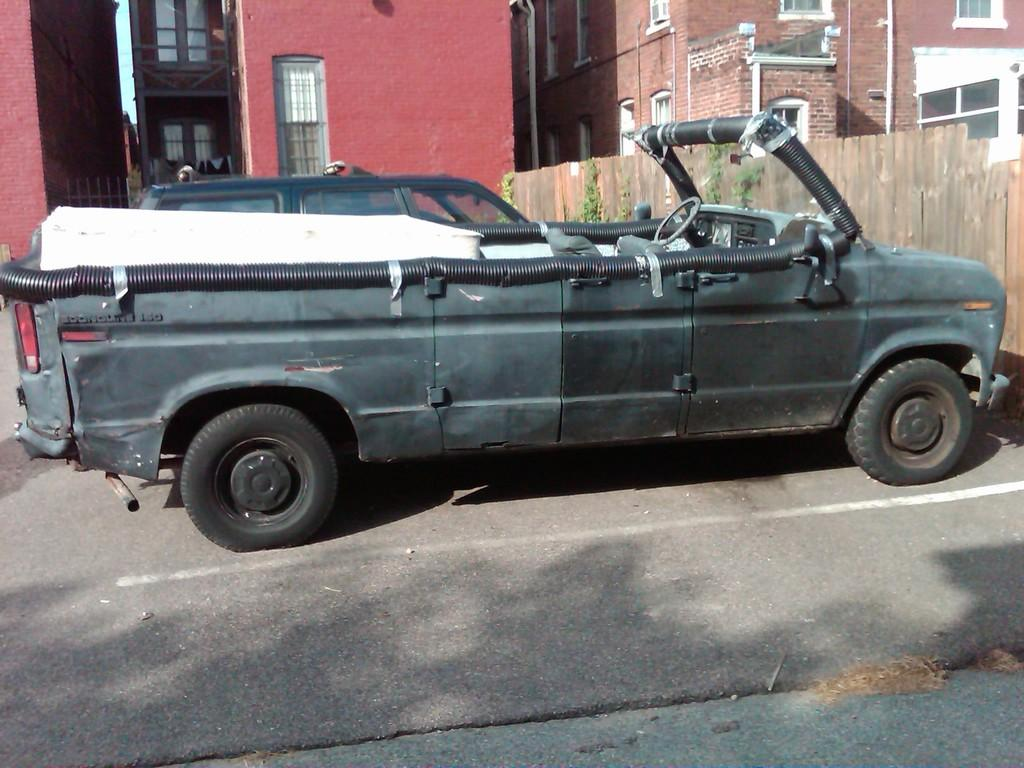What can be seen on the road in the image? There are vehicles on the road in the image. What is visible in the background of the image? There are buildings, windows, pipes, fences, plants, and the sky visible in the background of the image. How many babies are holding onto the string in the image? There are no babies or string present in the image. What type of wood can be seen in the image? There is no wood present in the image. 